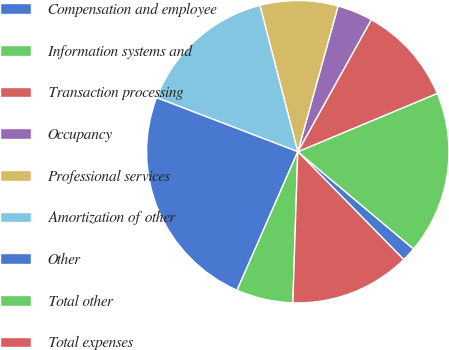Convert chart to OTSL. <chart><loc_0><loc_0><loc_500><loc_500><pie_chart><fcel>Compensation and employee<fcel>Information systems and<fcel>Transaction processing<fcel>Occupancy<fcel>Professional services<fcel>Amortization of other<fcel>Other<fcel>Total other<fcel>Total expenses<nl><fcel>1.52%<fcel>17.42%<fcel>10.61%<fcel>3.79%<fcel>8.33%<fcel>15.15%<fcel>24.24%<fcel>6.06%<fcel>12.88%<nl></chart> 